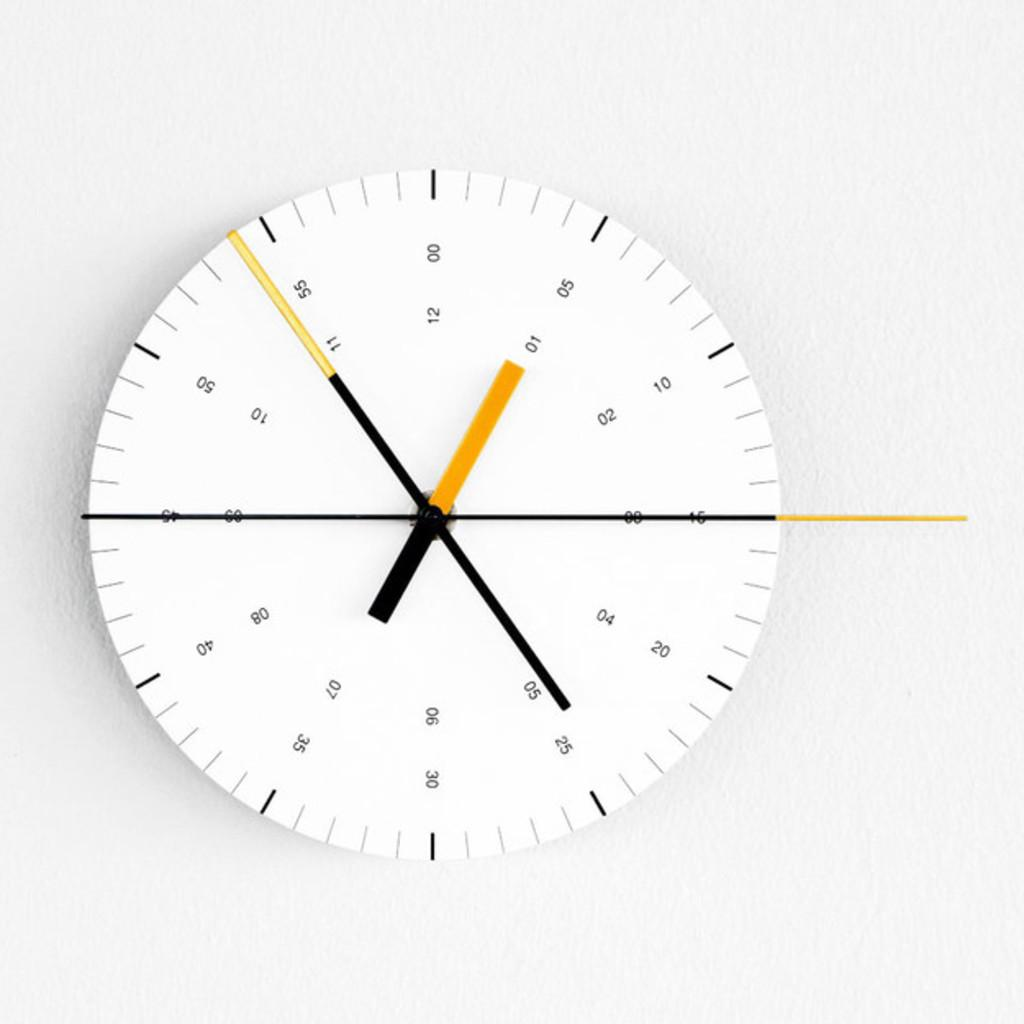<image>
Summarize the visual content of the image. A white circle has many numbers and tickmarks, including 04, 20, 11, and 55. 